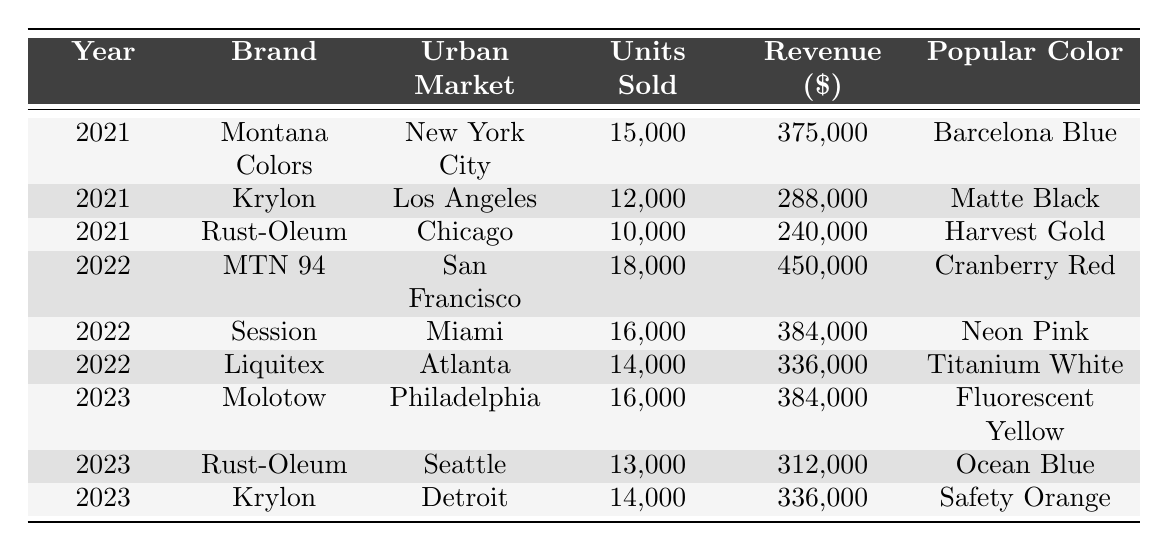What was the total revenue from sales of Rust-Oleum across all years? To find the total revenue for Rust-Oleum, we need to sum up the revenue from each year. In 2021, the revenue was $240,000 and in 2023, it was $312,000. Adding these amounts gives us $240,000 + $312,000 = $552,000.
Answer: $552,000 Which brand had the highest units sold in 2022? In 2022, we compare the units sold for each brand: MTN 94 had 18,000, Session had 16,000, and Liquitex had 14,000. Since 18,000 is the highest, MTN 94 sold the most units that year.
Answer: MTN 94 What is the popular color for Krylon in 2023? Referring to the table, Krylon's popular color in 2023 is listed as Safety Orange.
Answer: Safety Orange How many units did Molotow sell in 2023 compared to 2022? Molotow sold 16,000 units in 2023, but it didn't sell any units in 2022 (as it isn't listed for that year). The comparison shows that Molotow had a higher total in 2023 than in 2022 where it sold zero.
Answer: 16,000 (2023 is greater) Which urban market had the lowest revenue in the data presented? We need to look at the revenue for each entry. The revenues are: NYC $375,000, LA $288,000, Chicago $240,000, SF $450,000, Miami $384,000, Atlanta $336,000, Philadelphia $384,000, Seattle $312,000, and Detroit $336,000. The lowest revenue is from Chicago at $240,000.
Answer: Chicago What was the average units sold across all brands in 2021? In 2021, the units sold were: 15,000 (Montana Colors), 12,000 (Krylon), and 10,000 (Rust-Oleum). The total units sold is 15,000 + 12,000 + 10,000 = 37,000 units. There are 3 brands, so the average units sold is 37,000 / 3 = 12,333.
Answer: 12,333 Did any brand sell more than 15,000 units in 2021? In 2021, the sales were: Montana Colors (15,000 units), Krylon (12,000 units), and Rust-Oleum (10,000 units). Only Montana Colors met the threshold and did not surpass it. Thus, there was no brand that sold more than 15,000 units that year.
Answer: No What was the total units sold in the urban market of Miami from 2021 to 2023? Miami's units sold in the provided data is only from 2022 when Session sold 16,000 units. Therefore, no additional units are counted in 2021 or 2023. The total remains 16,000 from 2022.
Answer: 16,000 Which brand had consistent sales in both 2021 and 2023? By checking the table for brands listed in both years, we see Krylon is listed in both 2021 (12,000 units) and 2023 (14,000 units). The same brand presence indicates consistency in sales across those years.
Answer: Krylon Was there a brand that achieved the same revenue in two different years? We can see that Rust-Oleum had a revenue of $240,000 in 2021 and $312,000 in 2023, while none of the other brands repeated revenues across the years in the given data. Thus, differing revenues confirmed no brand had the same revenue in any two years.
Answer: No 